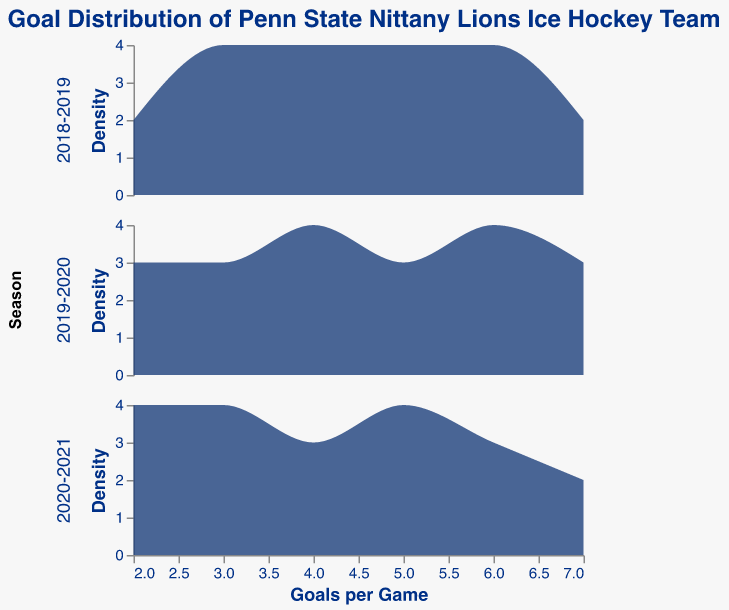What is the title of the plot? The title of the plot is written at the top of the figure.
Answer: Goal Distribution of Penn State Nittany Lions Ice Hockey Team How many seasons are represented in the plot? There are three different rows, each representing a different season in the plot.
Answer: 3 What is the range of goals per game shown on the x-axis? The x-axis shows the range of goals per game from the minimum to the maximum values present in the data. This can be checked by looking at the lowest and highest numbers on the x-axis.
Answer: 2 to 7 Which season seems to have the highest density of games with 5 goals? By comparing the peaks of the density plots across different seasons at the 5-goal mark, the season with the highest peak indicates the highest density.
Answer: 2018-2019 In which season did the Nittany Lions score exactly 7 goals in a game with the highest density? By analyzing the density heights at the 7-goal mark across the seasons, the season with the most prominent peak has the highest density.
Answer: 2020-2021 What is the mode of goals scored per game for the 2019-2020 season? The mode is the value that appears most frequently. To find it, look for the highest peak in the density plot for the 2019-2020 season.
Answer: 6 Do any of the seasons show a bimodal distribution of goals per game? A bimodal distribution has two distinct peaks in the density plot. Examine each season's plot to see if any have two significant peaks.
Answer: No Between 2018-2019 and 2020-2021, which season has a more uniformly distributed range of goals per game? A more uniformly distributed season will show a flatter density plot without sharp peaks. Compare the density plots of the two seasons to determine this.
Answer: 2018-2019 How does the density distribution of goals per game for the 2020-2021 season compare to the 2019-2020 season? To compare, observe the shape, height, and spread of the density plots for both seasons. Note any prominent differences or similarities in their distributions.
Answer: 2020-2021 has higher peaks at 2 and 7 goals; 2019-2020 is more centered around 4 to 6 goals 